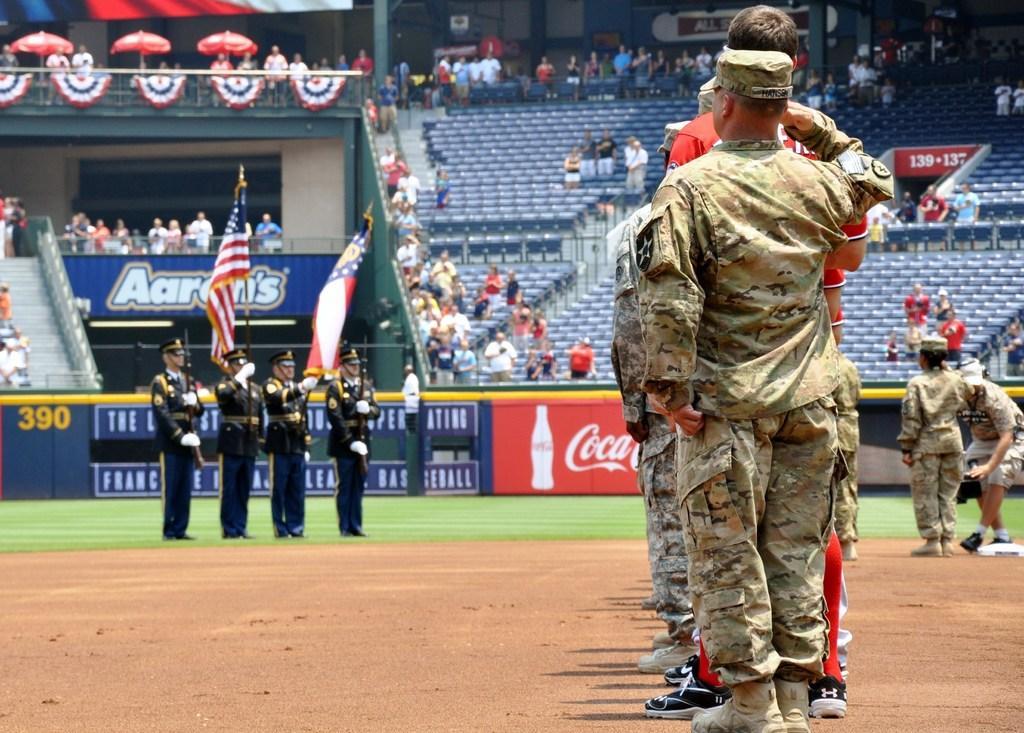Could you give a brief overview of what you see in this image? On the right there are few people standing on the ground and on the left there are 4 men standing on the grass and among them 2 men are holding flags in their hands. In the background there are few people standing at the chairs,fence and we can see fence,hoardings,poles,decorative items,umbrellas and some other items. On the right there are two persons standing on the ground. 